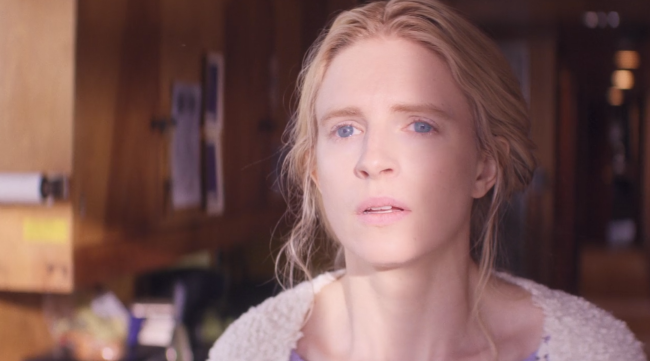Describe a possible brief scenario for this image. The woman in the image could be waiting for a loved one to arrive. She stands in the comfort of her home, looking out the window with a mix of anticipation and concern, wondering if everything is okay. 